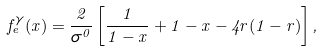<formula> <loc_0><loc_0><loc_500><loc_500>f _ { e } ^ { \gamma } ( x ) = \frac { 2 } { \sigma ^ { 0 } } \left [ \frac { 1 } { 1 - x } + 1 - x - 4 r ( 1 - r ) \right ] ,</formula> 